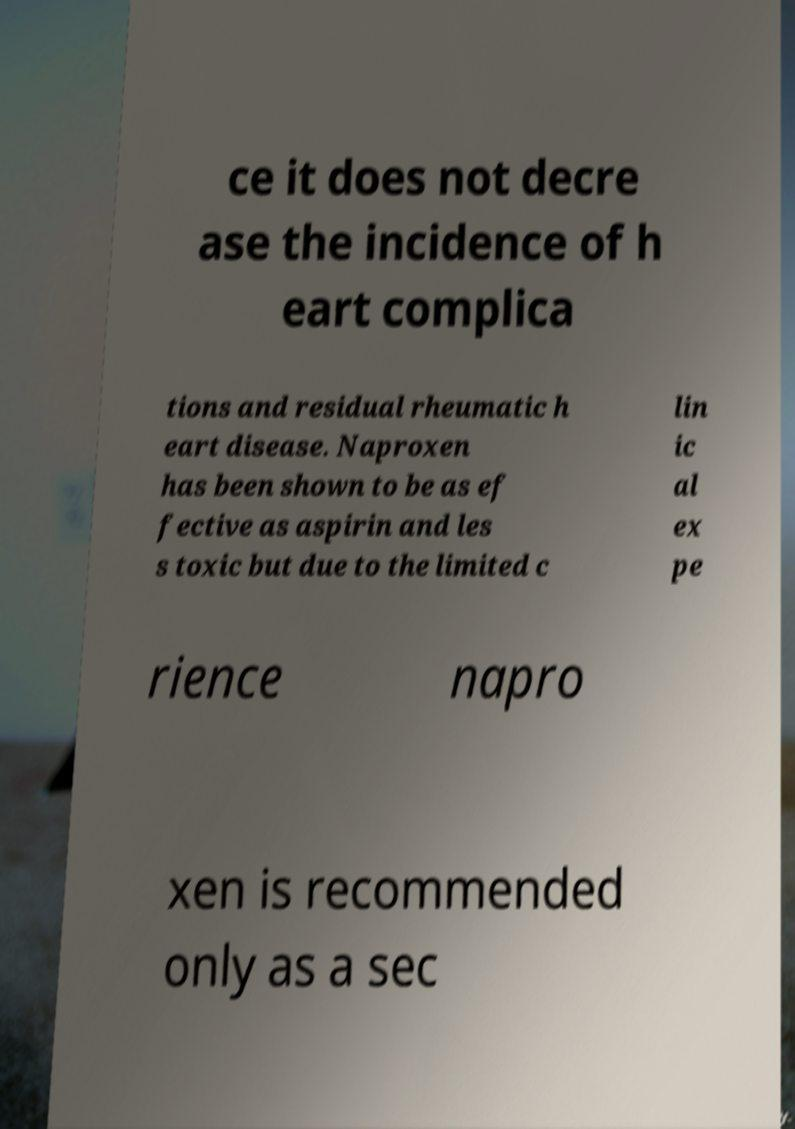For documentation purposes, I need the text within this image transcribed. Could you provide that? ce it does not decre ase the incidence of h eart complica tions and residual rheumatic h eart disease. Naproxen has been shown to be as ef fective as aspirin and les s toxic but due to the limited c lin ic al ex pe rience napro xen is recommended only as a sec 